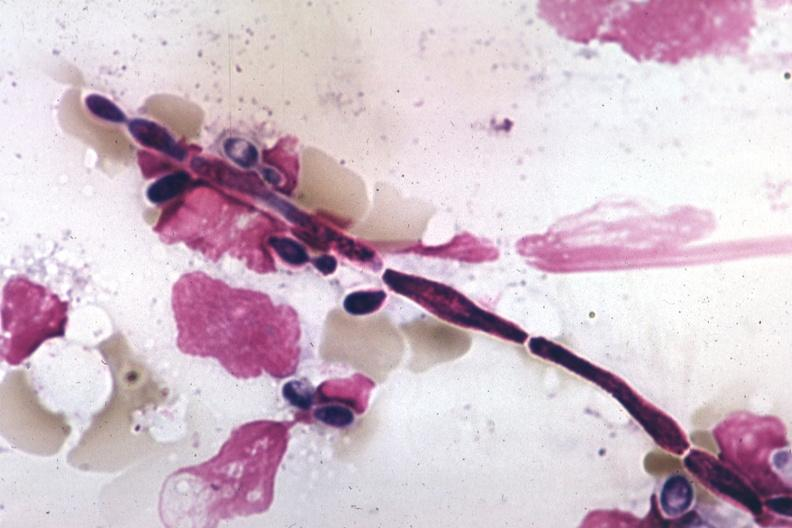s malignant adenoma present?
Answer the question using a single word or phrase. No 